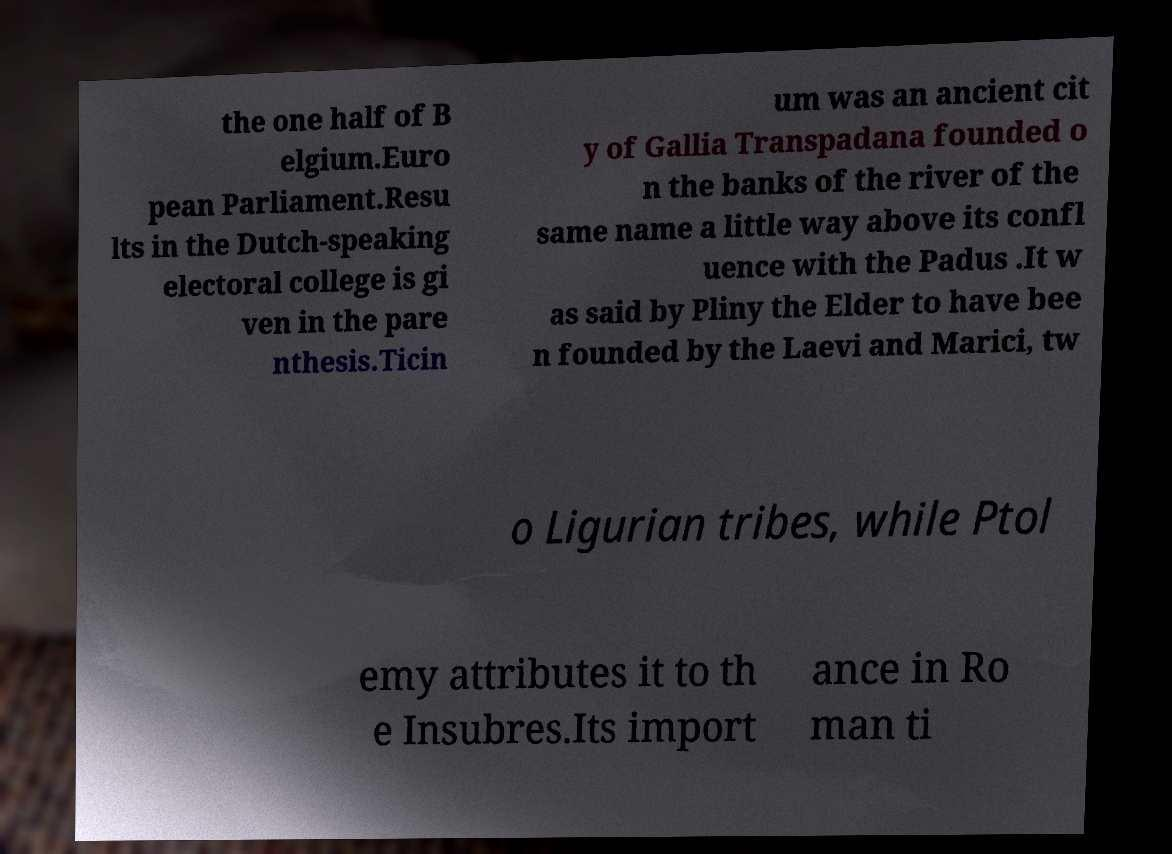Can you accurately transcribe the text from the provided image for me? the one half of B elgium.Euro pean Parliament.Resu lts in the Dutch-speaking electoral college is gi ven in the pare nthesis.Ticin um was an ancient cit y of Gallia Transpadana founded o n the banks of the river of the same name a little way above its confl uence with the Padus .It w as said by Pliny the Elder to have bee n founded by the Laevi and Marici, tw o Ligurian tribes, while Ptol emy attributes it to th e Insubres.Its import ance in Ro man ti 